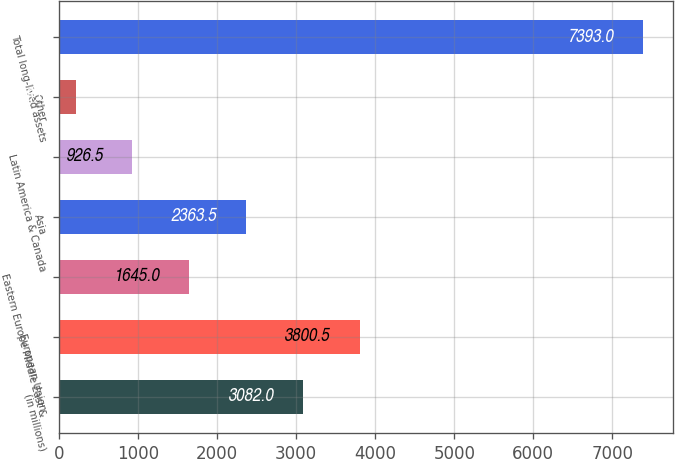<chart> <loc_0><loc_0><loc_500><loc_500><bar_chart><fcel>(in millions)<fcel>European Union<fcel>Eastern Europe Middle East &<fcel>Asia<fcel>Latin America & Canada<fcel>Other<fcel>Total long-lived assets<nl><fcel>3082<fcel>3800.5<fcel>1645<fcel>2363.5<fcel>926.5<fcel>208<fcel>7393<nl></chart> 